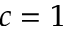Convert formula to latex. <formula><loc_0><loc_0><loc_500><loc_500>c = 1</formula> 